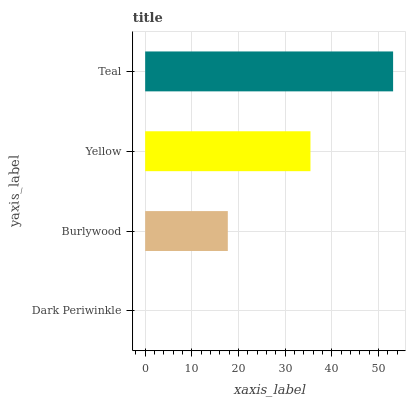Is Dark Periwinkle the minimum?
Answer yes or no. Yes. Is Teal the maximum?
Answer yes or no. Yes. Is Burlywood the minimum?
Answer yes or no. No. Is Burlywood the maximum?
Answer yes or no. No. Is Burlywood greater than Dark Periwinkle?
Answer yes or no. Yes. Is Dark Periwinkle less than Burlywood?
Answer yes or no. Yes. Is Dark Periwinkle greater than Burlywood?
Answer yes or no. No. Is Burlywood less than Dark Periwinkle?
Answer yes or no. No. Is Yellow the high median?
Answer yes or no. Yes. Is Burlywood the low median?
Answer yes or no. Yes. Is Teal the high median?
Answer yes or no. No. Is Dark Periwinkle the low median?
Answer yes or no. No. 